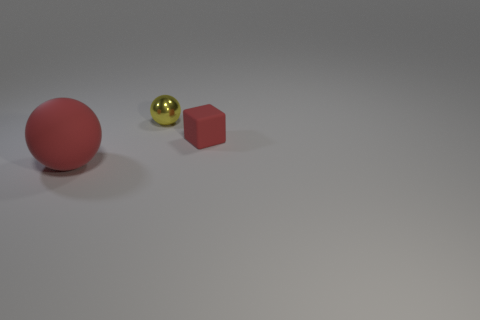Do the large red rubber object and the rubber object that is on the right side of the big red ball have the same shape?
Ensure brevity in your answer.  No. Is there anything else that is the same color as the rubber sphere?
Ensure brevity in your answer.  Yes. There is a matte object that is on the left side of the red matte cube; is its color the same as the object that is behind the red block?
Keep it short and to the point. No. Are there any big purple rubber cylinders?
Make the answer very short. No. Are there any big cyan cylinders that have the same material as the red block?
Give a very brief answer. No. Is there anything else that has the same material as the tiny yellow ball?
Keep it short and to the point. No. What color is the tiny shiny ball?
Offer a very short reply. Yellow. The matte object that is the same color as the matte cube is what shape?
Provide a short and direct response. Sphere. What is the color of the matte object that is the same size as the yellow sphere?
Provide a short and direct response. Red. What number of matte things are either red cubes or big red things?
Offer a terse response. 2. 